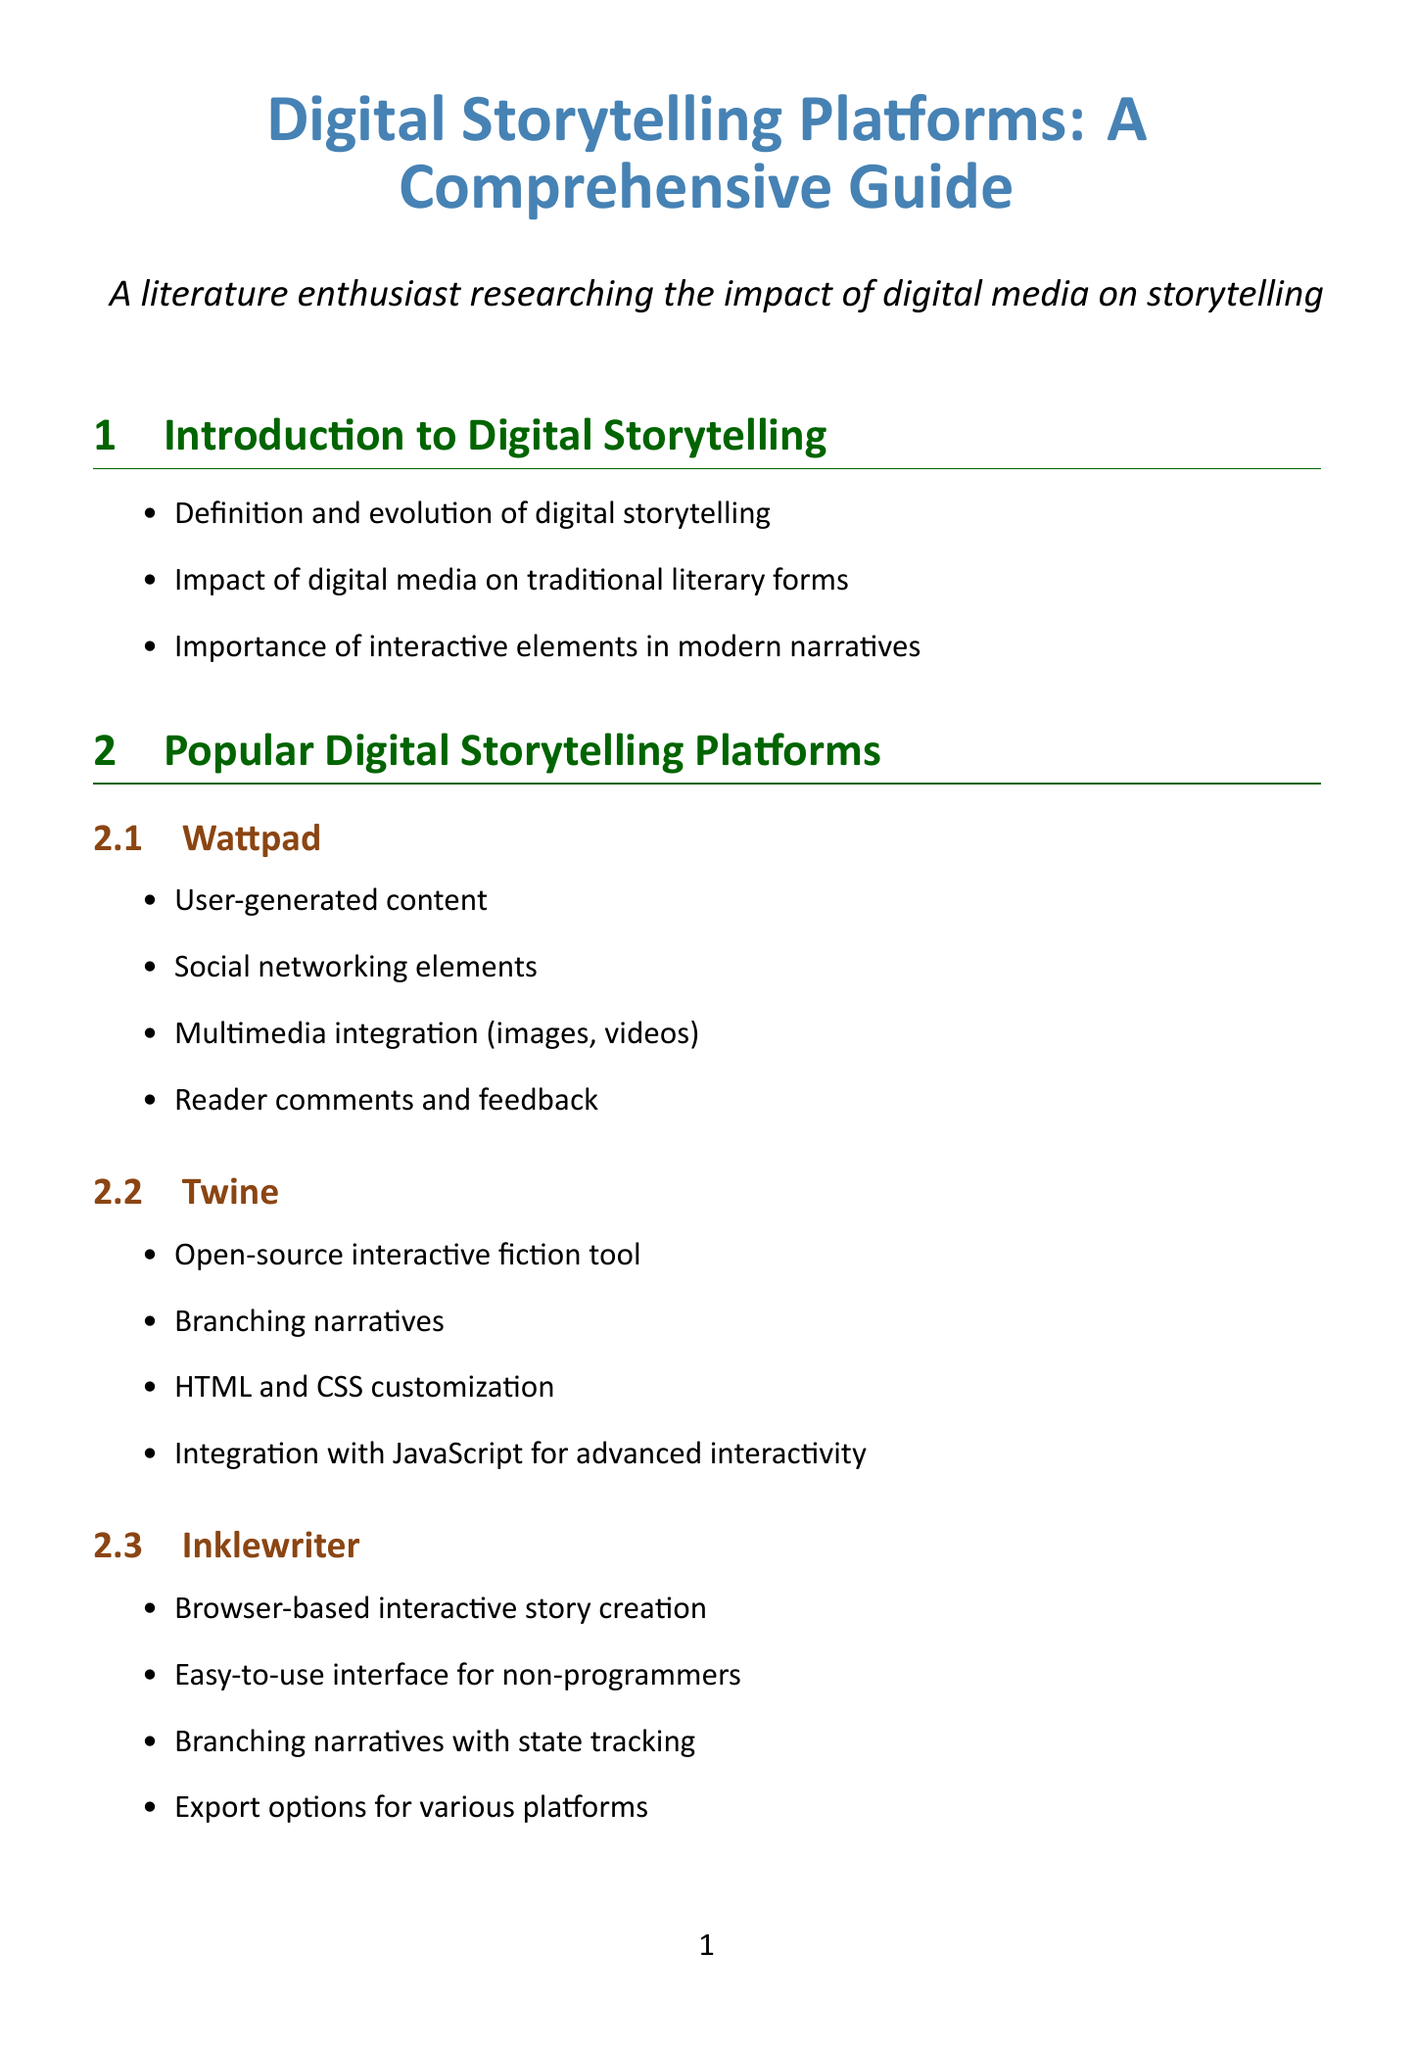What is the title of the document? The title is clearly stated at the beginning of the document.
Answer: Digital Storytelling Platforms: A Comprehensive Guide How many popular digital storytelling platforms are mentioned? The section lists a specific number of platforms.
Answer: Four What is a feature of Wattpad? The features for each platform are listed in bullet points.
Answer: User-generated content What type of narratives does Twine enable? Twine's capabilities are described in the features section.
Answer: Branching narratives What is the significance of "Black Mirror: Bandersnatch"? The importance of the case study is highlighted.
Answer: Mainstream adoption of interactive storytelling in streaming media Which multimedia integration technique is mentioned? The document lists several techniques under a specific section.
Answer: Embedding images and GIFs for visual storytelling What consideration is important for accessibility? The document has a dedicated section outlining various considerations.
Answer: Screen reader compatibility for text-based stories What type of analytics tool is Google Analytics? Google Analytics is identified alongside other tools.
Answer: Tracking reader behavior and demographics 